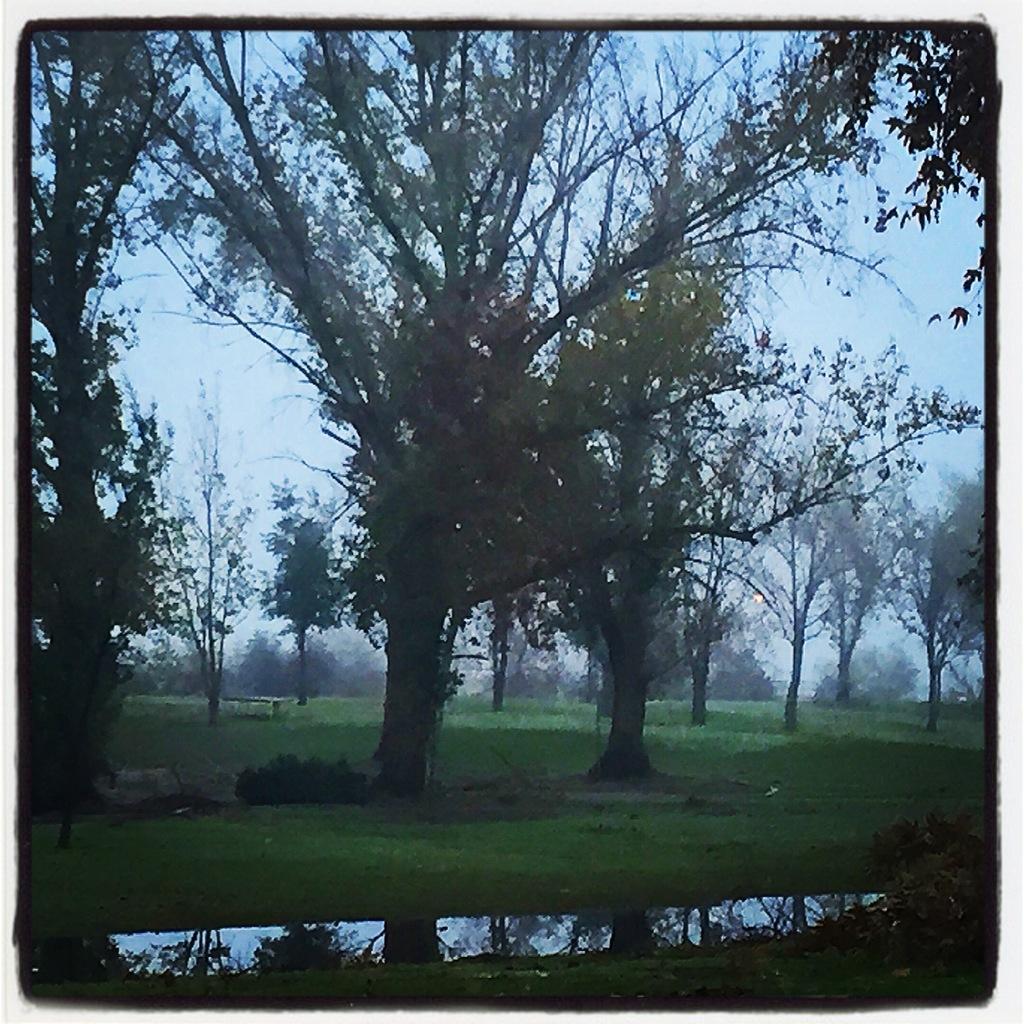What type of vegetation is in the middle of the image? There are trees in the middle of the image. What can be seen at the bottom of the image? There are plants and grass visible at the bottom of the image. Is there any water visible in the image? Yes, there is water visible at the bottom of the image. What part of the natural environment is visible at the top of the image? The sky is visible at the top of the image. What is the income of the trees in the image? There is no information about the income of the trees in the image, as trees do not have income. Can you describe the attempt made by the water to reach the sky in the image? There is no attempt made by the water to reach the sky in the image; the water is stationary at the bottom. 